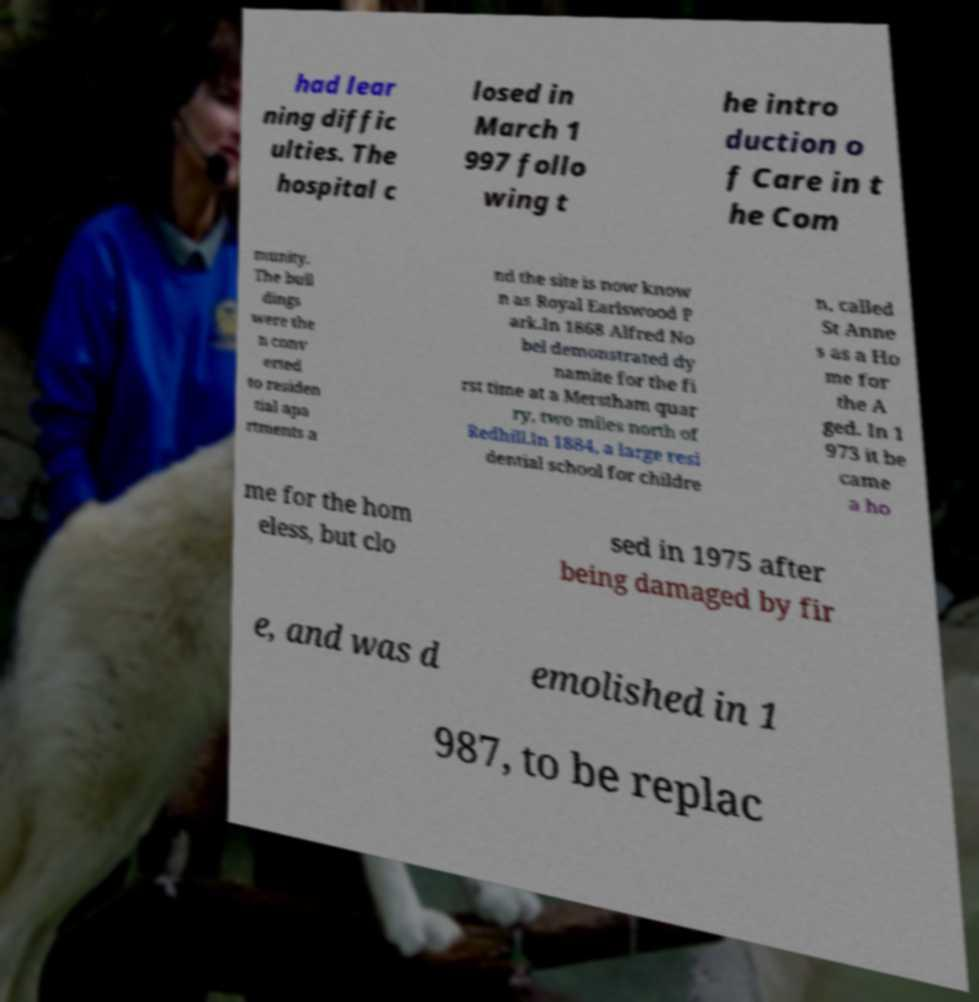Could you assist in decoding the text presented in this image and type it out clearly? had lear ning diffic ulties. The hospital c losed in March 1 997 follo wing t he intro duction o f Care in t he Com munity. The buil dings were the n conv erted to residen tial apa rtments a nd the site is now know n as Royal Earlswood P ark.In 1868 Alfred No bel demonstrated dy namite for the fi rst time at a Merstham quar ry, two miles north of Redhill.In 1884, a large resi dential school for childre n, called St Anne s as a Ho me for the A ged. In 1 973 it be came a ho me for the hom eless, but clo sed in 1975 after being damaged by fir e, and was d emolished in 1 987, to be replac 